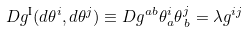<formula> <loc_0><loc_0><loc_500><loc_500>D g ^ { \text {I} } ( d \theta ^ { i } , d \theta ^ { j } ) \equiv D g ^ { a b } \theta _ { a } ^ { i } \theta _ { \, b } ^ { j } = \lambda g ^ { i j }</formula> 